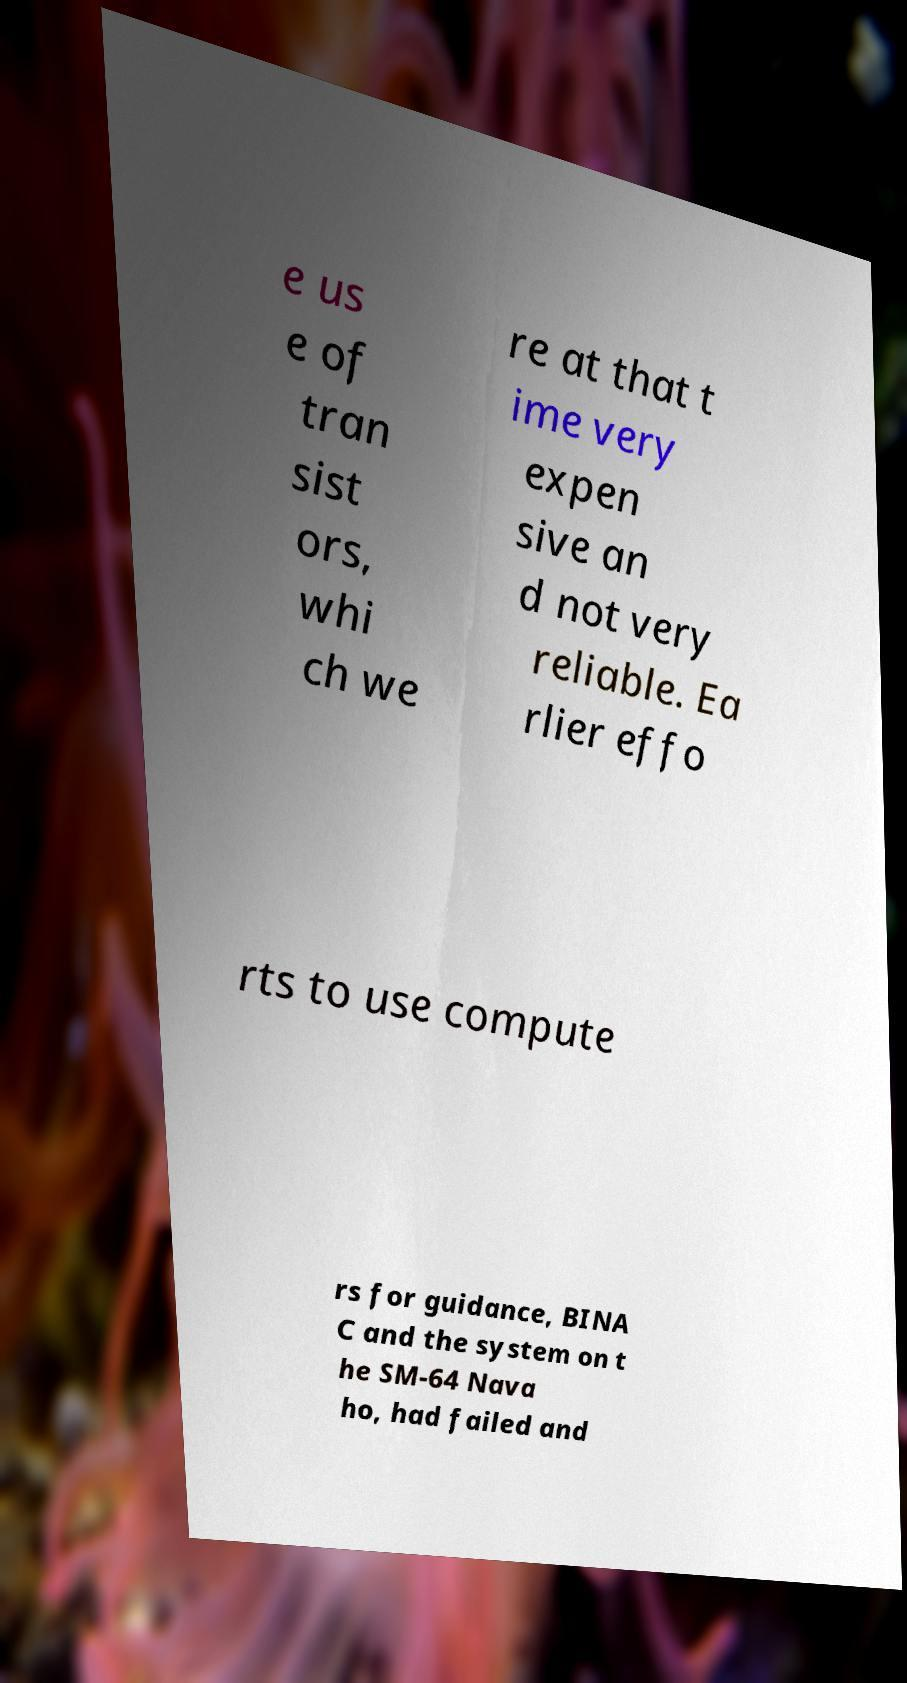Please identify and transcribe the text found in this image. e us e of tran sist ors, whi ch we re at that t ime very expen sive an d not very reliable. Ea rlier effo rts to use compute rs for guidance, BINA C and the system on t he SM-64 Nava ho, had failed and 